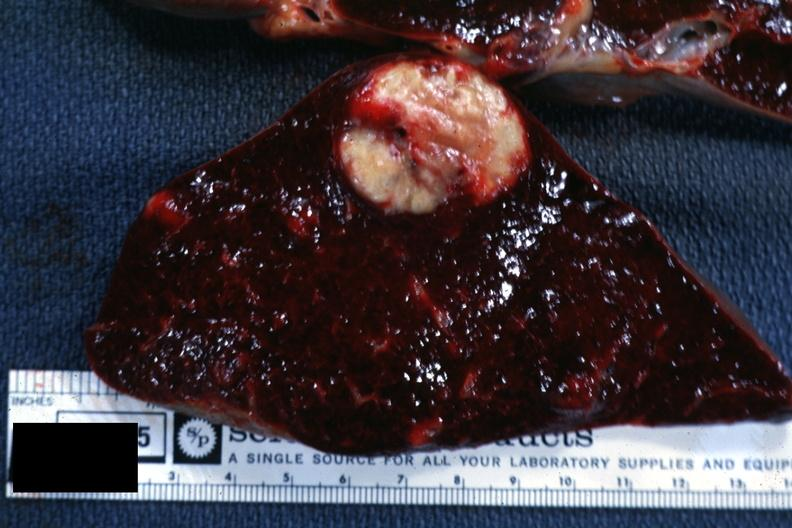s metastatic carcinoma present?
Answer the question using a single word or phrase. Yes 